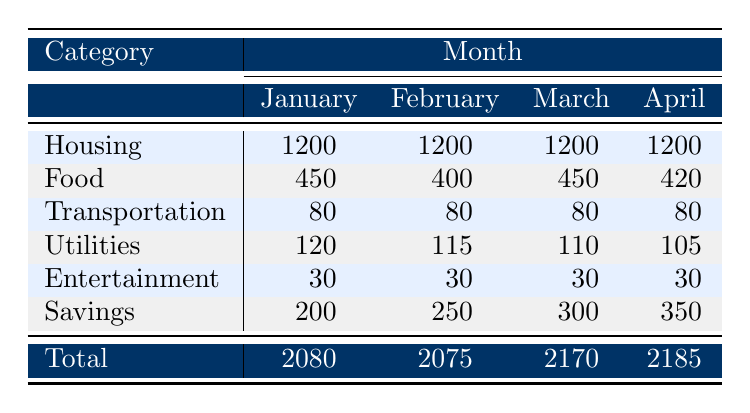What was the total amount spent on Utilities in January? To find the total spent on Utilities in January, I look at the row under the Utilities category and find the amount listed, which is 120.
Answer: 120 What is the average amount spent on Food in the four months? To calculate the average, I first sum the values for Food across all four months: (450 + 400 + 450 + 420) = 1720. Then I divide this sum by the number of months, which is 4: 1720 / 4 = 430.
Answer: 430 Did the amount spent on Savings increase from January to April? Comparing the values for Savings in January (200) and April (350), I see that the amount in April is greater than in January, which indicates an increase.
Answer: Yes What was the highest spending category in February? I examine the total amounts for each category in February. The highest spending is 1200 for the Housing category since all other categories are less than that value in February.
Answer: Housing How much more was spent on Food in March compared to February? The total amount spent on Food in March is 450, while in February it is 400. To find the difference, I subtract 400 from 450: 450 - 400 = 50.
Answer: 50 What percentage of the total budget was spent on Housing in January? The total budget for January is 2080. The amount spent on Housing is 1200. To find the percentage, I calculate (1200 / 2080) * 100 = 57.69%.
Answer: 57.69% Is the total spending in April greater than the total spending in January? The total spending in January is 2080, and in April, it is 2185. Since 2185 is greater than 2080, the statement is true.
Answer: Yes What is the total amount spent on Entertainment over the four months? I find the amount spent on Entertainment for each month and sum them up: 30 + 30 + 30 + 30 = 120.
Answer: 120 Which category had the least amount spent in March? I check the spending amounts for each category in March and see that Transportation (80) is the least amount spent compared to other categories.
Answer: Transportation 